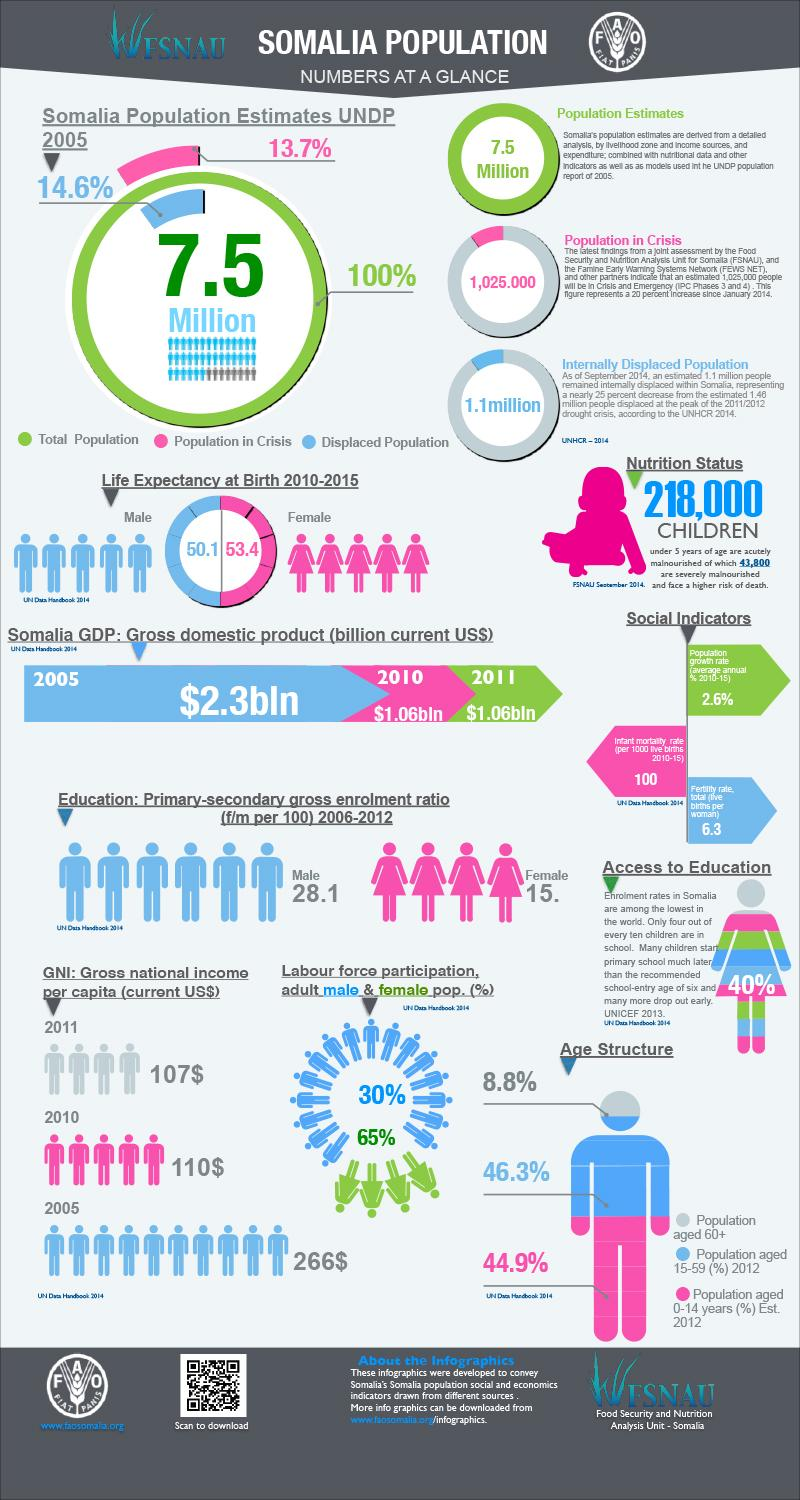Indicate a few pertinent items in this graphic. In 2012, approximately 8.8% of the Somalia population was aged 60 or older. The adult male population in Somalia constitutes 30% of the labor force. According to data from 2010 to 2015, the life expectancy for females at birth in Somalia was 53.4 years. The female labor force participation rate in Somalia is 65%. The primary-secondary gross enrolment ratio of male students in Somalia was 28.1 students per 100 during the period 2006-2012. 